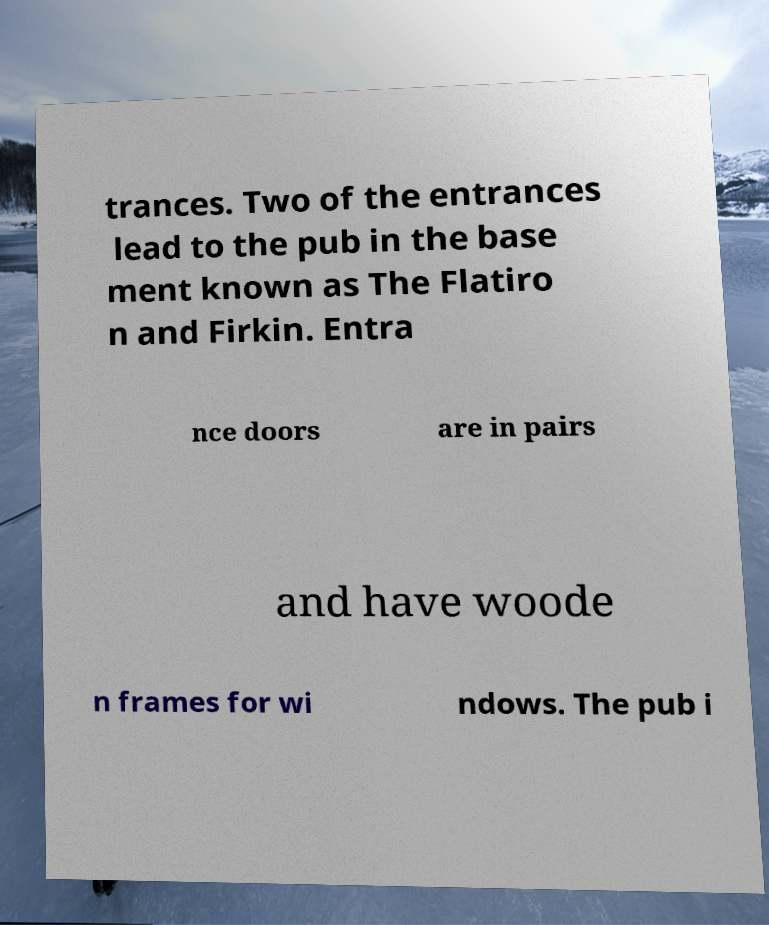I need the written content from this picture converted into text. Can you do that? trances. Two of the entrances lead to the pub in the base ment known as The Flatiro n and Firkin. Entra nce doors are in pairs and have woode n frames for wi ndows. The pub i 